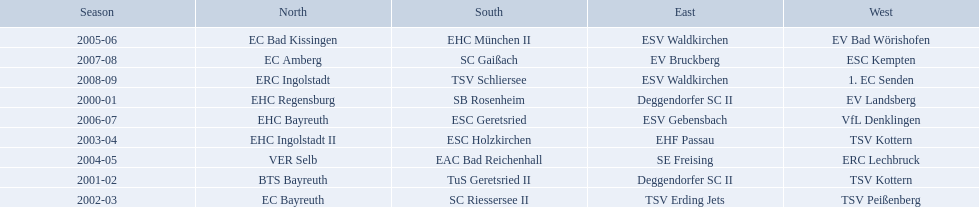Which teams played in the north? EHC Regensburg, BTS Bayreuth, EC Bayreuth, EHC Ingolstadt II, VER Selb, EC Bad Kissingen, EHC Bayreuth, EC Amberg, ERC Ingolstadt. Of these teams, which played during 2000-2001? EHC Regensburg. 